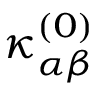<formula> <loc_0><loc_0><loc_500><loc_500>{ \kappa } _ { \alpha \beta } ^ { ( 0 ) }</formula> 